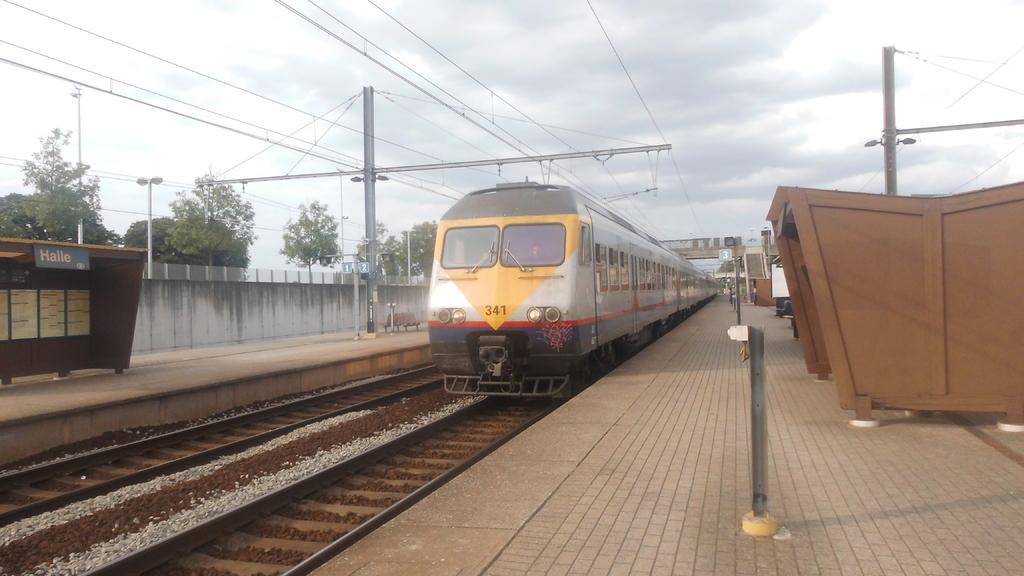Please provide a concise description of this image. In this image I see the train over here and I see the platforms on which there are rods and I see the wires and I see the tracks over here. In the background I see the trees and the cloudy sky. 